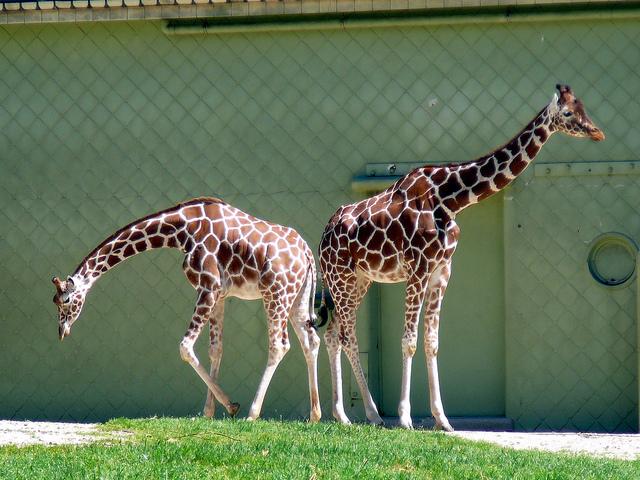Is this their natural habitat?
Answer briefly. No. How many giraffes?
Be succinct. 2. What kind of slope do their necks form?
Give a very brief answer. Downward. 